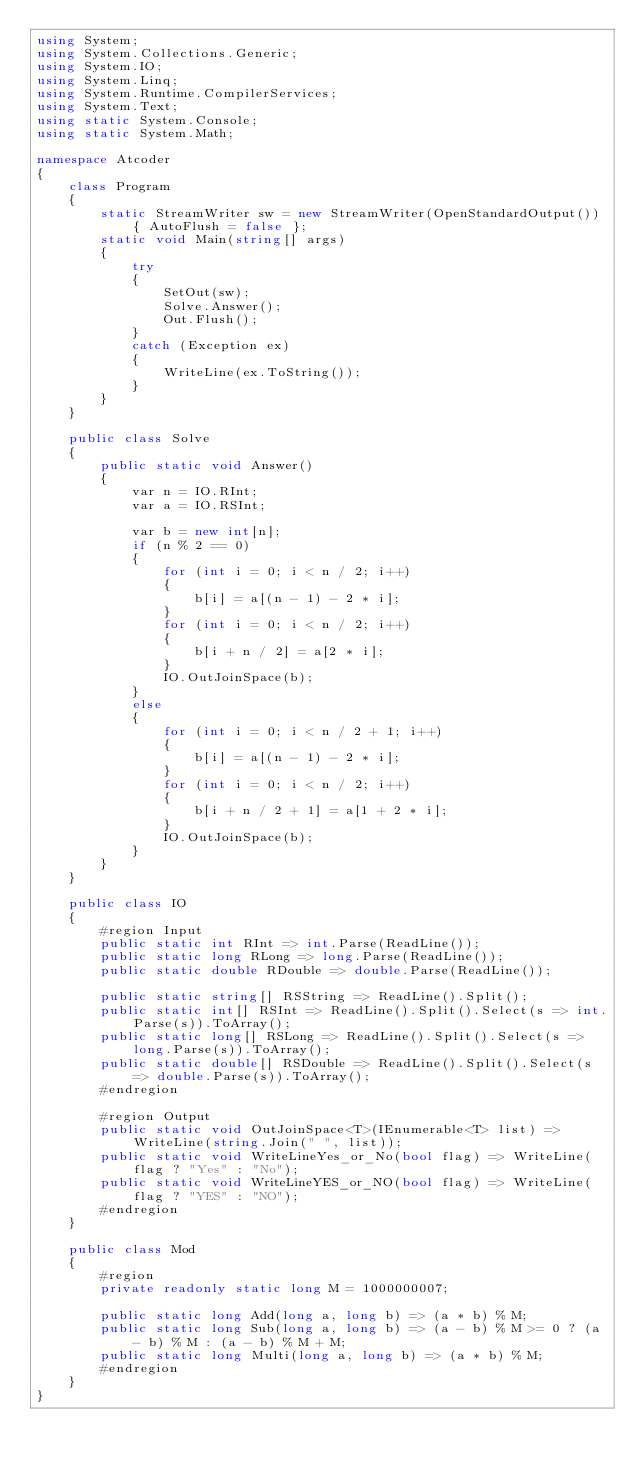Convert code to text. <code><loc_0><loc_0><loc_500><loc_500><_C#_>using System;
using System.Collections.Generic;
using System.IO;
using System.Linq;
using System.Runtime.CompilerServices;
using System.Text;
using static System.Console;
using static System.Math;

namespace Atcoder
{
    class Program
    {
        static StreamWriter sw = new StreamWriter(OpenStandardOutput()) { AutoFlush = false };
        static void Main(string[] args)
        {
            try
            {
                SetOut(sw);
                Solve.Answer();
                Out.Flush();
            }
            catch (Exception ex)
            {
                WriteLine(ex.ToString());
            }
        }
    }

    public class Solve
    {
        public static void Answer()
        {
            var n = IO.RInt;
            var a = IO.RSInt;

            var b = new int[n];
            if (n % 2 == 0)
            {
                for (int i = 0; i < n / 2; i++)
                {
                    b[i] = a[(n - 1) - 2 * i];
                }
                for (int i = 0; i < n / 2; i++)
                {
                    b[i + n / 2] = a[2 * i];
                }
                IO.OutJoinSpace(b);
            }
            else
            {
                for (int i = 0; i < n / 2 + 1; i++)
                {
                    b[i] = a[(n - 1) - 2 * i];
                }
                for (int i = 0; i < n / 2; i++)
                {
                    b[i + n / 2 + 1] = a[1 + 2 * i];
                }
                IO.OutJoinSpace(b);
            }
        }
    }

    public class IO
    {
        #region Input
        public static int RInt => int.Parse(ReadLine());
        public static long RLong => long.Parse(ReadLine());
        public static double RDouble => double.Parse(ReadLine());

        public static string[] RSString => ReadLine().Split();
        public static int[] RSInt => ReadLine().Split().Select(s => int.Parse(s)).ToArray();
        public static long[] RSLong => ReadLine().Split().Select(s => long.Parse(s)).ToArray();
        public static double[] RSDouble => ReadLine().Split().Select(s => double.Parse(s)).ToArray();
        #endregion

        #region Output
        public static void OutJoinSpace<T>(IEnumerable<T> list) => WriteLine(string.Join(" ", list));
        public static void WriteLineYes_or_No(bool flag) => WriteLine(flag ? "Yes" : "No");
        public static void WriteLineYES_or_NO(bool flag) => WriteLine(flag ? "YES" : "NO");
        #endregion
    }

    public class Mod
    {
        #region
        private readonly static long M = 1000000007;

        public static long Add(long a, long b) => (a * b) % M;
        public static long Sub(long a, long b) => (a - b) % M >= 0 ? (a - b) % M : (a - b) % M + M;
        public static long Multi(long a, long b) => (a * b) % M;
        #endregion
    }
}</code> 